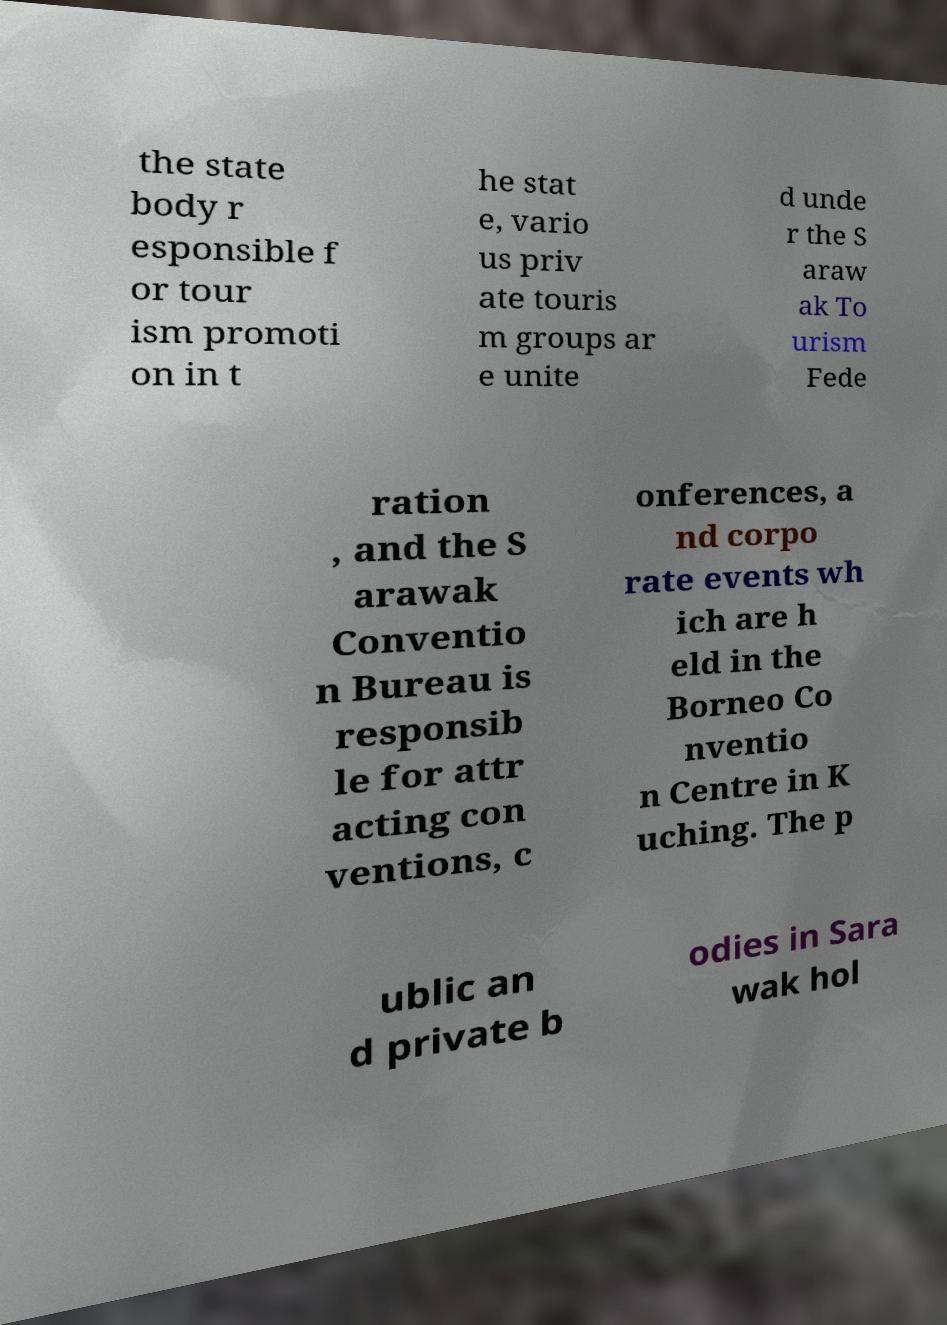Can you accurately transcribe the text from the provided image for me? the state body r esponsible f or tour ism promoti on in t he stat e, vario us priv ate touris m groups ar e unite d unde r the S araw ak To urism Fede ration , and the S arawak Conventio n Bureau is responsib le for attr acting con ventions, c onferences, a nd corpo rate events wh ich are h eld in the Borneo Co nventio n Centre in K uching. The p ublic an d private b odies in Sara wak hol 